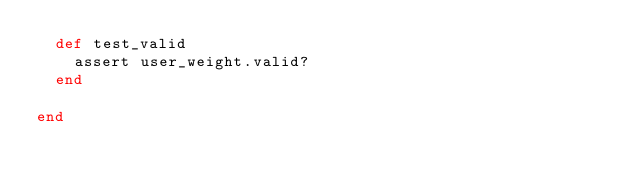Convert code to text. <code><loc_0><loc_0><loc_500><loc_500><_Ruby_>  def test_valid
    assert user_weight.valid?
  end

end
</code> 